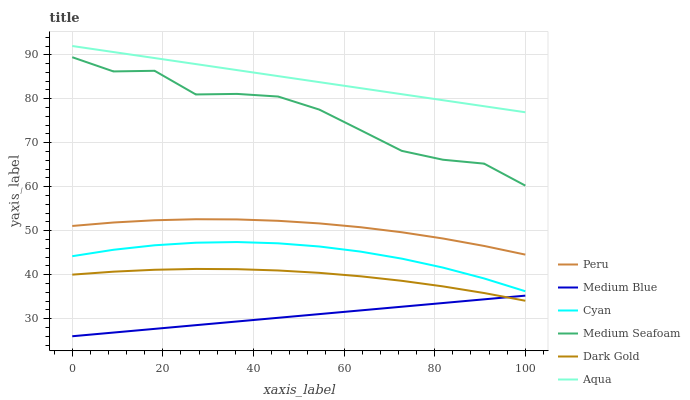Does Medium Blue have the minimum area under the curve?
Answer yes or no. Yes. Does Aqua have the maximum area under the curve?
Answer yes or no. Yes. Does Aqua have the minimum area under the curve?
Answer yes or no. No. Does Medium Blue have the maximum area under the curve?
Answer yes or no. No. Is Medium Blue the smoothest?
Answer yes or no. Yes. Is Medium Seafoam the roughest?
Answer yes or no. Yes. Is Aqua the smoothest?
Answer yes or no. No. Is Aqua the roughest?
Answer yes or no. No. Does Medium Blue have the lowest value?
Answer yes or no. Yes. Does Aqua have the lowest value?
Answer yes or no. No. Does Aqua have the highest value?
Answer yes or no. Yes. Does Medium Blue have the highest value?
Answer yes or no. No. Is Medium Blue less than Medium Seafoam?
Answer yes or no. Yes. Is Peru greater than Dark Gold?
Answer yes or no. Yes. Does Dark Gold intersect Medium Blue?
Answer yes or no. Yes. Is Dark Gold less than Medium Blue?
Answer yes or no. No. Is Dark Gold greater than Medium Blue?
Answer yes or no. No. Does Medium Blue intersect Medium Seafoam?
Answer yes or no. No. 